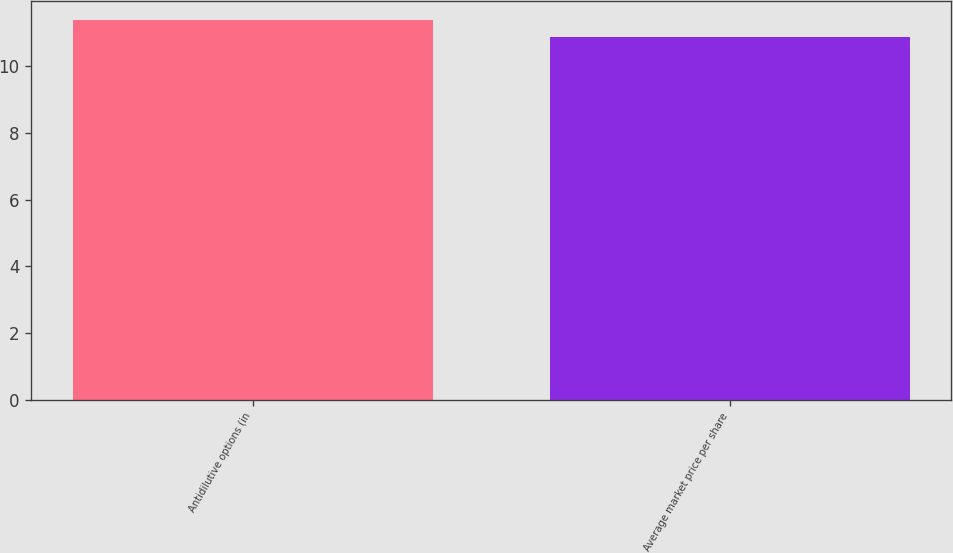Convert chart to OTSL. <chart><loc_0><loc_0><loc_500><loc_500><bar_chart><fcel>Antidilutive options (in<fcel>Average market price per share<nl><fcel>11.4<fcel>10.88<nl></chart> 